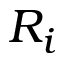<formula> <loc_0><loc_0><loc_500><loc_500>R _ { i }</formula> 